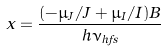Convert formula to latex. <formula><loc_0><loc_0><loc_500><loc_500>x = \frac { ( - \mu _ { J } / J + \mu _ { I } / I ) B } { h \nu _ { h f s } }</formula> 